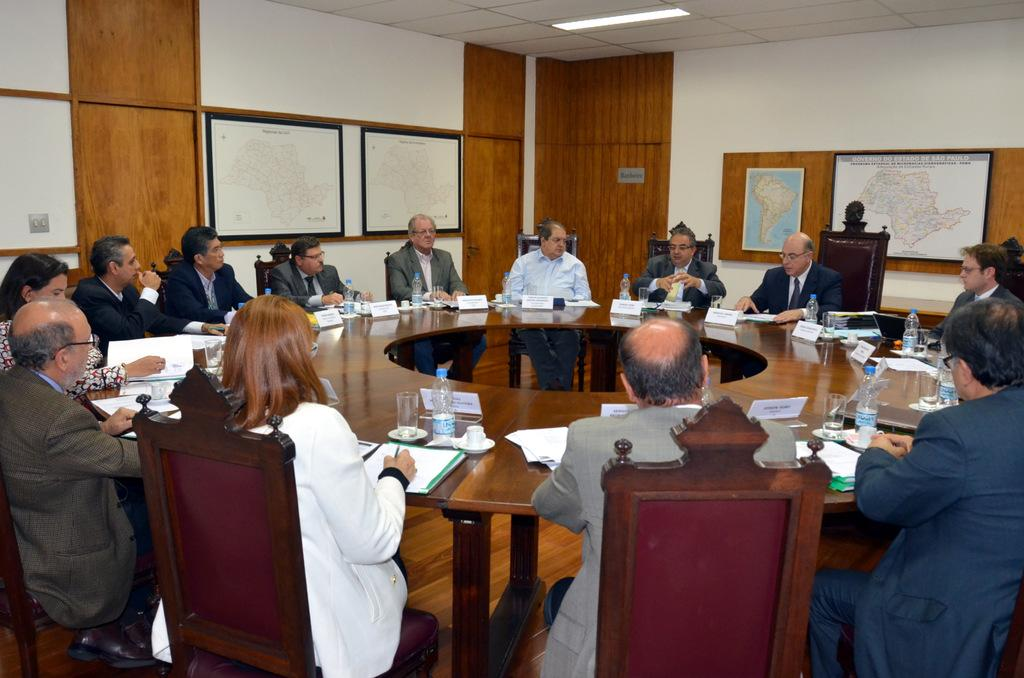What are the people in the image doing? The people in the image are sitting on chairs. What type of table is in the image? There is a round table in the image. What is on the round table? There are bottles on the round table. What can be seen on the wall in the image? There are maps on the wall in the image. What type of insurance is being discussed at the table in the image? There is no indication of any insurance discussion in the image; it only shows people sitting on chairs, a round table with bottles, and maps on the wall. 